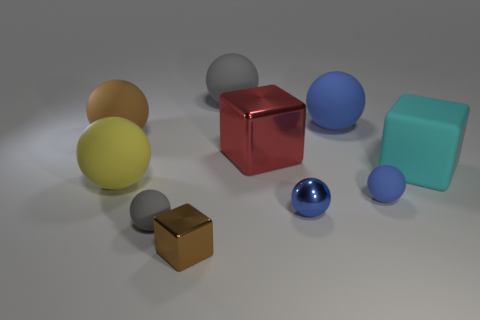What number of rubber objects are either big red blocks or yellow balls?
Offer a terse response. 1. What number of large red metallic cylinders are there?
Provide a short and direct response. 0. The shiny block that is the same size as the metallic sphere is what color?
Keep it short and to the point. Brown. Does the red object have the same size as the matte cube?
Make the answer very short. Yes. There is a large matte thing that is the same color as the shiny ball; what shape is it?
Keep it short and to the point. Sphere. There is a red shiny cube; is its size the same as the blue shiny thing behind the small brown object?
Provide a short and direct response. No. There is a big matte sphere that is on the right side of the tiny block and in front of the large gray thing; what color is it?
Give a very brief answer. Blue. Is the number of blue matte spheres that are behind the big matte block greater than the number of tiny blue matte spheres that are behind the large brown object?
Ensure brevity in your answer.  Yes. What is the size of the brown object that is the same material as the large red object?
Your answer should be very brief. Small. There is a big rubber sphere that is to the left of the yellow matte sphere; how many large brown rubber spheres are left of it?
Offer a terse response. 0. 